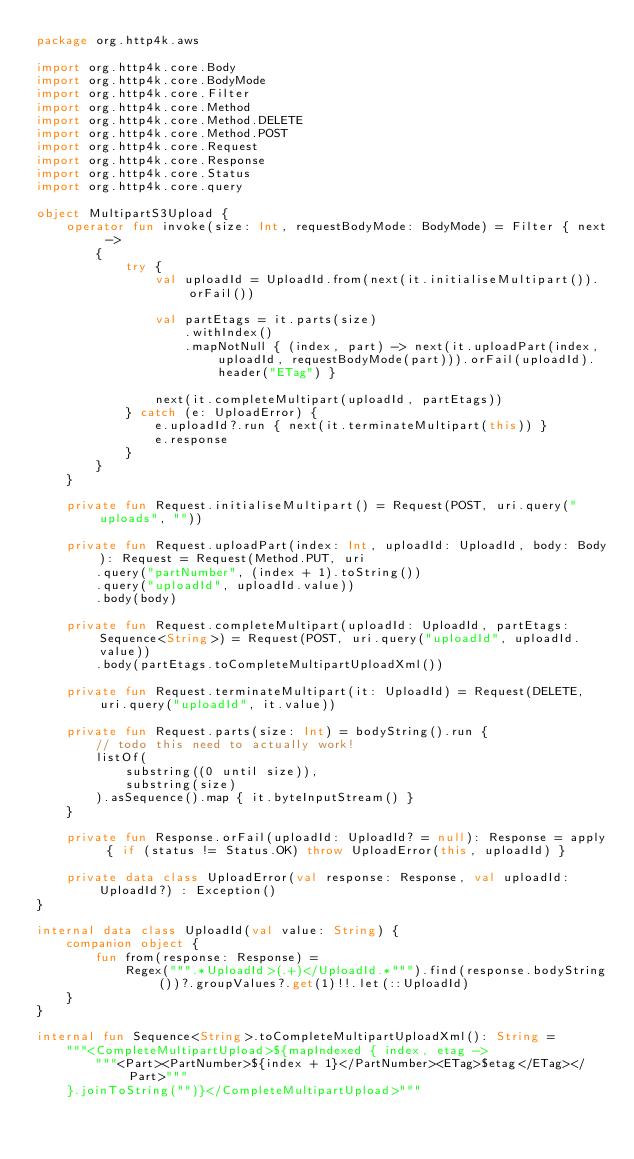<code> <loc_0><loc_0><loc_500><loc_500><_Kotlin_>package org.http4k.aws

import org.http4k.core.Body
import org.http4k.core.BodyMode
import org.http4k.core.Filter
import org.http4k.core.Method
import org.http4k.core.Method.DELETE
import org.http4k.core.Method.POST
import org.http4k.core.Request
import org.http4k.core.Response
import org.http4k.core.Status
import org.http4k.core.query

object MultipartS3Upload {
    operator fun invoke(size: Int, requestBodyMode: BodyMode) = Filter { next ->
        {
            try {
                val uploadId = UploadId.from(next(it.initialiseMultipart()).orFail())

                val partEtags = it.parts(size)
                    .withIndex()
                    .mapNotNull { (index, part) -> next(it.uploadPart(index, uploadId, requestBodyMode(part))).orFail(uploadId).header("ETag") }

                next(it.completeMultipart(uploadId, partEtags))
            } catch (e: UploadError) {
                e.uploadId?.run { next(it.terminateMultipart(this)) }
                e.response
            }
        }
    }

    private fun Request.initialiseMultipart() = Request(POST, uri.query("uploads", ""))

    private fun Request.uploadPart(index: Int, uploadId: UploadId, body: Body): Request = Request(Method.PUT, uri
        .query("partNumber", (index + 1).toString())
        .query("uploadId", uploadId.value))
        .body(body)

    private fun Request.completeMultipart(uploadId: UploadId, partEtags: Sequence<String>) = Request(POST, uri.query("uploadId", uploadId.value))
        .body(partEtags.toCompleteMultipartUploadXml())

    private fun Request.terminateMultipart(it: UploadId) = Request(DELETE, uri.query("uploadId", it.value))

    private fun Request.parts(size: Int) = bodyString().run {
        // todo this need to actually work!
        listOf(
            substring((0 until size)),
            substring(size)
        ).asSequence().map { it.byteInputStream() }
    }

    private fun Response.orFail(uploadId: UploadId? = null): Response = apply { if (status != Status.OK) throw UploadError(this, uploadId) }

    private data class UploadError(val response: Response, val uploadId: UploadId?) : Exception()
}

internal data class UploadId(val value: String) {
    companion object {
        fun from(response: Response) =
            Regex(""".*UploadId>(.+)</UploadId.*""").find(response.bodyString())?.groupValues?.get(1)!!.let(::UploadId)
    }
}

internal fun Sequence<String>.toCompleteMultipartUploadXml(): String =
    """<CompleteMultipartUpload>${mapIndexed { index, etag ->
        """<Part><PartNumber>${index + 1}</PartNumber><ETag>$etag</ETag></Part>"""
    }.joinToString("")}</CompleteMultipartUpload>"""
</code> 